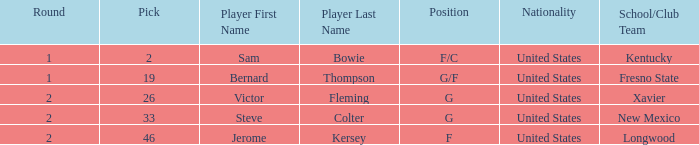What is the highest Pick, when Position is "G/F"? 19.0. 